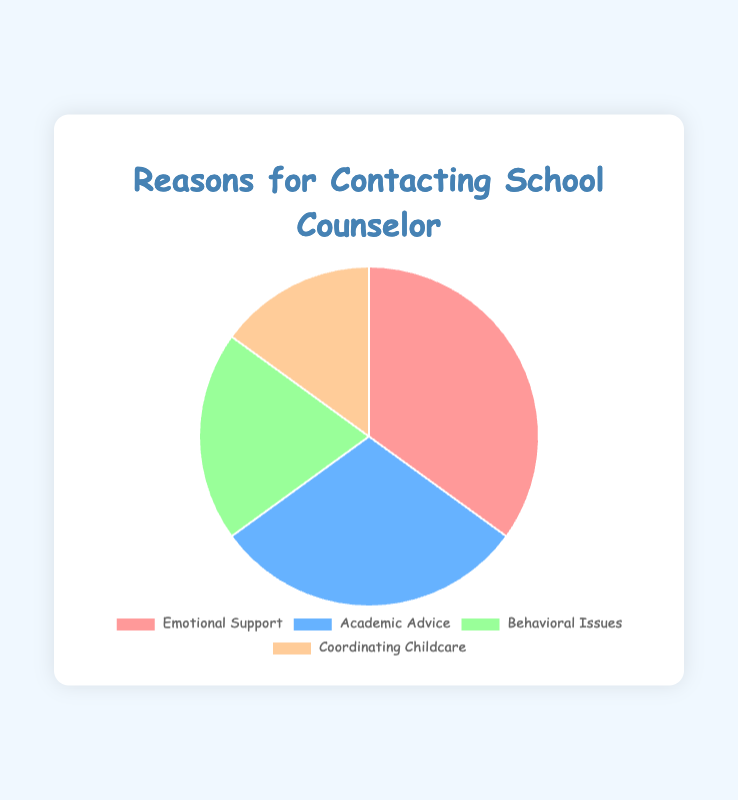What's the largest reason for contacting the school counselor? The largest percentage from the pie chart is indicated by the section labeled "Emotional Support," which has a value of 35%.
Answer: Emotional Support Which two reasons combined make up more than half of the reasons for contacting the school counselor? Adding the percentages for "Emotional Support" (35%) and "Academic Advice" (30%) gives 35% + 30% = 65%, which is more than half.
Answer: Emotional Support and Academic Advice What's the difference in percentage between the highest and lowest reasons for contacting the school counselor? The highest reason is "Emotional Support" at 35% and the lowest is "Coordinating Childcare" at 15%. The difference is 35% - 15% = 20%.
Answer: 20% Which reason for contacting the school counselor is represented by the blue section of the pie chart? The blue section corresponds to the "Academic Advice" category, as indicated by its color and position in the legend.
Answer: Academic Advice Compare the number of people contacting the school counselor for behavioral issues to those contacting for coordinating childcare. Which is higher and by how much? The pie chart shows "Behavioral Issues" at 20% and "Coordinating Childcare" at 15%. The difference is 20% - 15% = 5%.
Answer: Behavioral Issues by 5% What is the total percentage of people contacting the school counselor for reasons related to their children (academic advice for children and behavioral issues)? Summing the percentages for "Academic Advice" (30%) and "Behavioral Issues" (20%) gives 30% + 20% = 50%.
Answer: 50% If the total number of contacts to the school counselor is 100, how many contacts are for emotional support? If 35% of the total 100 contacts are for emotional support, then 35% of 100 is 35 contacts.
Answer: 35 What proportion of the pie chart is dedicated to coordinating childcare? The section labeled "Coordinating Childcare" represents 15% of the pie chart.
Answer: 15% If the total number of contacts made in a month is 200, how many contacts were made for academic advice and behavioral issues combined? Academic Advice is 30% and Behavioral Issues is 20%, totaling 50%. So, 50% of 200 is 0.50 * 200 = 100 contacts.
Answer: 100 